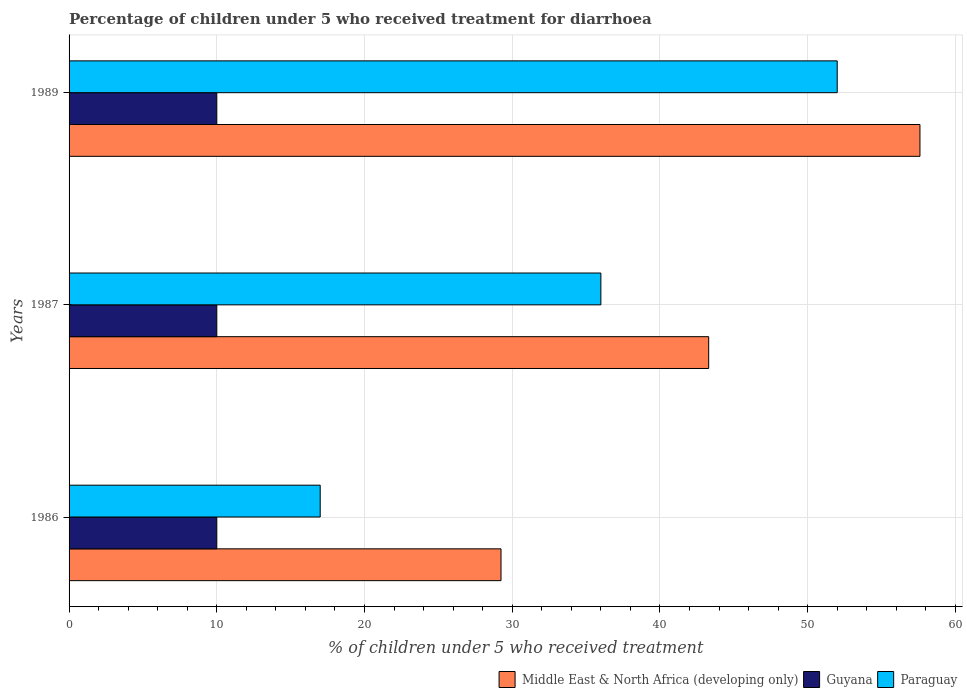How many groups of bars are there?
Your answer should be compact. 3. How many bars are there on the 3rd tick from the bottom?
Your answer should be compact. 3. What is the label of the 3rd group of bars from the top?
Make the answer very short. 1986. Across all years, what is the maximum percentage of children who received treatment for diarrhoea  in Guyana?
Offer a very short reply. 10. In which year was the percentage of children who received treatment for diarrhoea  in Guyana minimum?
Provide a succinct answer. 1986. What is the total percentage of children who received treatment for diarrhoea  in Paraguay in the graph?
Keep it short and to the point. 105. What is the difference between the percentage of children who received treatment for diarrhoea  in Guyana in 1987 and that in 1989?
Your answer should be compact. 0. What is the difference between the percentage of children who received treatment for diarrhoea  in Middle East & North Africa (developing only) in 1989 and the percentage of children who received treatment for diarrhoea  in Guyana in 1986?
Offer a very short reply. 47.6. In the year 1986, what is the difference between the percentage of children who received treatment for diarrhoea  in Guyana and percentage of children who received treatment for diarrhoea  in Middle East & North Africa (developing only)?
Your response must be concise. -19.24. In how many years, is the percentage of children who received treatment for diarrhoea  in Guyana greater than 50 %?
Your response must be concise. 0. What is the ratio of the percentage of children who received treatment for diarrhoea  in Guyana in 1987 to that in 1989?
Give a very brief answer. 1. Is the percentage of children who received treatment for diarrhoea  in Paraguay in 1986 less than that in 1989?
Give a very brief answer. Yes. What is the difference between the highest and the second highest percentage of children who received treatment for diarrhoea  in Paraguay?
Your answer should be very brief. 16. What is the difference between the highest and the lowest percentage of children who received treatment for diarrhoea  in Paraguay?
Make the answer very short. 35. In how many years, is the percentage of children who received treatment for diarrhoea  in Middle East & North Africa (developing only) greater than the average percentage of children who received treatment for diarrhoea  in Middle East & North Africa (developing only) taken over all years?
Offer a terse response. 1. What does the 3rd bar from the top in 1987 represents?
Offer a very short reply. Middle East & North Africa (developing only). What does the 3rd bar from the bottom in 1987 represents?
Offer a terse response. Paraguay. Is it the case that in every year, the sum of the percentage of children who received treatment for diarrhoea  in Guyana and percentage of children who received treatment for diarrhoea  in Paraguay is greater than the percentage of children who received treatment for diarrhoea  in Middle East & North Africa (developing only)?
Give a very brief answer. No. How many bars are there?
Ensure brevity in your answer.  9. Are all the bars in the graph horizontal?
Provide a short and direct response. Yes. Are the values on the major ticks of X-axis written in scientific E-notation?
Provide a short and direct response. No. Does the graph contain grids?
Your answer should be very brief. Yes. How many legend labels are there?
Ensure brevity in your answer.  3. How are the legend labels stacked?
Offer a terse response. Horizontal. What is the title of the graph?
Provide a succinct answer. Percentage of children under 5 who received treatment for diarrhoea. What is the label or title of the X-axis?
Keep it short and to the point. % of children under 5 who received treatment. What is the % of children under 5 who received treatment of Middle East & North Africa (developing only) in 1986?
Your answer should be compact. 29.24. What is the % of children under 5 who received treatment in Paraguay in 1986?
Your response must be concise. 17. What is the % of children under 5 who received treatment in Middle East & North Africa (developing only) in 1987?
Your answer should be compact. 43.3. What is the % of children under 5 who received treatment of Paraguay in 1987?
Your answer should be very brief. 36. What is the % of children under 5 who received treatment of Middle East & North Africa (developing only) in 1989?
Your answer should be very brief. 57.6. Across all years, what is the maximum % of children under 5 who received treatment of Middle East & North Africa (developing only)?
Your answer should be compact. 57.6. Across all years, what is the minimum % of children under 5 who received treatment of Middle East & North Africa (developing only)?
Your answer should be very brief. 29.24. What is the total % of children under 5 who received treatment of Middle East & North Africa (developing only) in the graph?
Ensure brevity in your answer.  130.14. What is the total % of children under 5 who received treatment of Guyana in the graph?
Make the answer very short. 30. What is the total % of children under 5 who received treatment of Paraguay in the graph?
Make the answer very short. 105. What is the difference between the % of children under 5 who received treatment of Middle East & North Africa (developing only) in 1986 and that in 1987?
Offer a terse response. -14.06. What is the difference between the % of children under 5 who received treatment in Middle East & North Africa (developing only) in 1986 and that in 1989?
Provide a short and direct response. -28.36. What is the difference between the % of children under 5 who received treatment of Paraguay in 1986 and that in 1989?
Give a very brief answer. -35. What is the difference between the % of children under 5 who received treatment in Middle East & North Africa (developing only) in 1987 and that in 1989?
Provide a succinct answer. -14.3. What is the difference between the % of children under 5 who received treatment in Paraguay in 1987 and that in 1989?
Your response must be concise. -16. What is the difference between the % of children under 5 who received treatment of Middle East & North Africa (developing only) in 1986 and the % of children under 5 who received treatment of Guyana in 1987?
Give a very brief answer. 19.24. What is the difference between the % of children under 5 who received treatment in Middle East & North Africa (developing only) in 1986 and the % of children under 5 who received treatment in Paraguay in 1987?
Give a very brief answer. -6.76. What is the difference between the % of children under 5 who received treatment of Guyana in 1986 and the % of children under 5 who received treatment of Paraguay in 1987?
Your answer should be very brief. -26. What is the difference between the % of children under 5 who received treatment of Middle East & North Africa (developing only) in 1986 and the % of children under 5 who received treatment of Guyana in 1989?
Your answer should be compact. 19.24. What is the difference between the % of children under 5 who received treatment in Middle East & North Africa (developing only) in 1986 and the % of children under 5 who received treatment in Paraguay in 1989?
Provide a succinct answer. -22.76. What is the difference between the % of children under 5 who received treatment in Guyana in 1986 and the % of children under 5 who received treatment in Paraguay in 1989?
Provide a succinct answer. -42. What is the difference between the % of children under 5 who received treatment in Middle East & North Africa (developing only) in 1987 and the % of children under 5 who received treatment in Guyana in 1989?
Your response must be concise. 33.3. What is the difference between the % of children under 5 who received treatment in Middle East & North Africa (developing only) in 1987 and the % of children under 5 who received treatment in Paraguay in 1989?
Your answer should be very brief. -8.7. What is the difference between the % of children under 5 who received treatment of Guyana in 1987 and the % of children under 5 who received treatment of Paraguay in 1989?
Ensure brevity in your answer.  -42. What is the average % of children under 5 who received treatment in Middle East & North Africa (developing only) per year?
Keep it short and to the point. 43.38. What is the average % of children under 5 who received treatment of Guyana per year?
Ensure brevity in your answer.  10. What is the average % of children under 5 who received treatment in Paraguay per year?
Make the answer very short. 35. In the year 1986, what is the difference between the % of children under 5 who received treatment in Middle East & North Africa (developing only) and % of children under 5 who received treatment in Guyana?
Make the answer very short. 19.24. In the year 1986, what is the difference between the % of children under 5 who received treatment in Middle East & North Africa (developing only) and % of children under 5 who received treatment in Paraguay?
Your answer should be compact. 12.24. In the year 1986, what is the difference between the % of children under 5 who received treatment of Guyana and % of children under 5 who received treatment of Paraguay?
Provide a short and direct response. -7. In the year 1987, what is the difference between the % of children under 5 who received treatment of Middle East & North Africa (developing only) and % of children under 5 who received treatment of Guyana?
Provide a succinct answer. 33.3. In the year 1987, what is the difference between the % of children under 5 who received treatment in Middle East & North Africa (developing only) and % of children under 5 who received treatment in Paraguay?
Your answer should be compact. 7.3. In the year 1989, what is the difference between the % of children under 5 who received treatment in Middle East & North Africa (developing only) and % of children under 5 who received treatment in Guyana?
Your answer should be very brief. 47.6. In the year 1989, what is the difference between the % of children under 5 who received treatment of Middle East & North Africa (developing only) and % of children under 5 who received treatment of Paraguay?
Offer a terse response. 5.6. In the year 1989, what is the difference between the % of children under 5 who received treatment of Guyana and % of children under 5 who received treatment of Paraguay?
Give a very brief answer. -42. What is the ratio of the % of children under 5 who received treatment of Middle East & North Africa (developing only) in 1986 to that in 1987?
Make the answer very short. 0.68. What is the ratio of the % of children under 5 who received treatment of Guyana in 1986 to that in 1987?
Give a very brief answer. 1. What is the ratio of the % of children under 5 who received treatment in Paraguay in 1986 to that in 1987?
Offer a very short reply. 0.47. What is the ratio of the % of children under 5 who received treatment in Middle East & North Africa (developing only) in 1986 to that in 1989?
Offer a very short reply. 0.51. What is the ratio of the % of children under 5 who received treatment in Paraguay in 1986 to that in 1989?
Ensure brevity in your answer.  0.33. What is the ratio of the % of children under 5 who received treatment of Middle East & North Africa (developing only) in 1987 to that in 1989?
Your answer should be very brief. 0.75. What is the ratio of the % of children under 5 who received treatment of Guyana in 1987 to that in 1989?
Give a very brief answer. 1. What is the ratio of the % of children under 5 who received treatment in Paraguay in 1987 to that in 1989?
Make the answer very short. 0.69. What is the difference between the highest and the second highest % of children under 5 who received treatment of Middle East & North Africa (developing only)?
Make the answer very short. 14.3. What is the difference between the highest and the second highest % of children under 5 who received treatment in Guyana?
Give a very brief answer. 0. What is the difference between the highest and the lowest % of children under 5 who received treatment of Middle East & North Africa (developing only)?
Ensure brevity in your answer.  28.36. What is the difference between the highest and the lowest % of children under 5 who received treatment in Guyana?
Provide a short and direct response. 0. What is the difference between the highest and the lowest % of children under 5 who received treatment in Paraguay?
Provide a short and direct response. 35. 